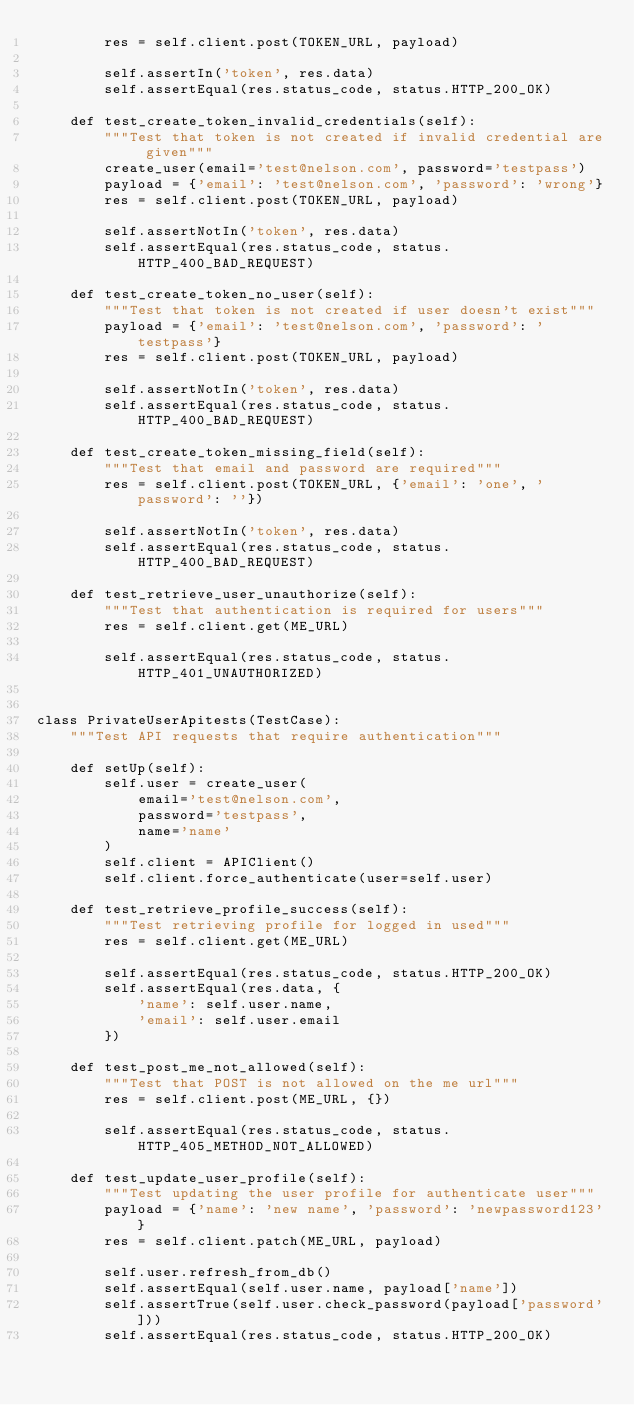<code> <loc_0><loc_0><loc_500><loc_500><_Python_>        res = self.client.post(TOKEN_URL, payload)

        self.assertIn('token', res.data)
        self.assertEqual(res.status_code, status.HTTP_200_OK)

    def test_create_token_invalid_credentials(self):
        """Test that token is not created if invalid credential are given"""
        create_user(email='test@nelson.com', password='testpass')
        payload = {'email': 'test@nelson.com', 'password': 'wrong'}
        res = self.client.post(TOKEN_URL, payload)

        self.assertNotIn('token', res.data)
        self.assertEqual(res.status_code, status.HTTP_400_BAD_REQUEST)

    def test_create_token_no_user(self):
        """Test that token is not created if user doesn't exist"""
        payload = {'email': 'test@nelson.com', 'password': 'testpass'}
        res = self.client.post(TOKEN_URL, payload)

        self.assertNotIn('token', res.data)
        self.assertEqual(res.status_code, status.HTTP_400_BAD_REQUEST)

    def test_create_token_missing_field(self):
        """Test that email and password are required"""
        res = self.client.post(TOKEN_URL, {'email': 'one', 'password': ''})

        self.assertNotIn('token', res.data)
        self.assertEqual(res.status_code, status.HTTP_400_BAD_REQUEST)

    def test_retrieve_user_unauthorize(self):
        """Test that authentication is required for users"""
        res = self.client.get(ME_URL)

        self.assertEqual(res.status_code, status.HTTP_401_UNAUTHORIZED)


class PrivateUserApitests(TestCase):
    """Test API requests that require authentication"""

    def setUp(self):
        self.user = create_user(
            email='test@nelson.com',
            password='testpass',
            name='name'
        )
        self.client = APIClient()
        self.client.force_authenticate(user=self.user)

    def test_retrieve_profile_success(self):
        """Test retrieving profile for logged in used"""
        res = self.client.get(ME_URL)

        self.assertEqual(res.status_code, status.HTTP_200_OK)
        self.assertEqual(res.data, {
            'name': self.user.name,
            'email': self.user.email
        })

    def test_post_me_not_allowed(self):
        """Test that POST is not allowed on the me url"""
        res = self.client.post(ME_URL, {})

        self.assertEqual(res.status_code, status.HTTP_405_METHOD_NOT_ALLOWED)

    def test_update_user_profile(self):
        """Test updating the user profile for authenticate user"""
        payload = {'name': 'new name', 'password': 'newpassword123'}
        res = self.client.patch(ME_URL, payload)

        self.user.refresh_from_db()
        self.assertEqual(self.user.name, payload['name'])
        self.assertTrue(self.user.check_password(payload['password']))
        self.assertEqual(res.status_code, status.HTTP_200_OK)
</code> 